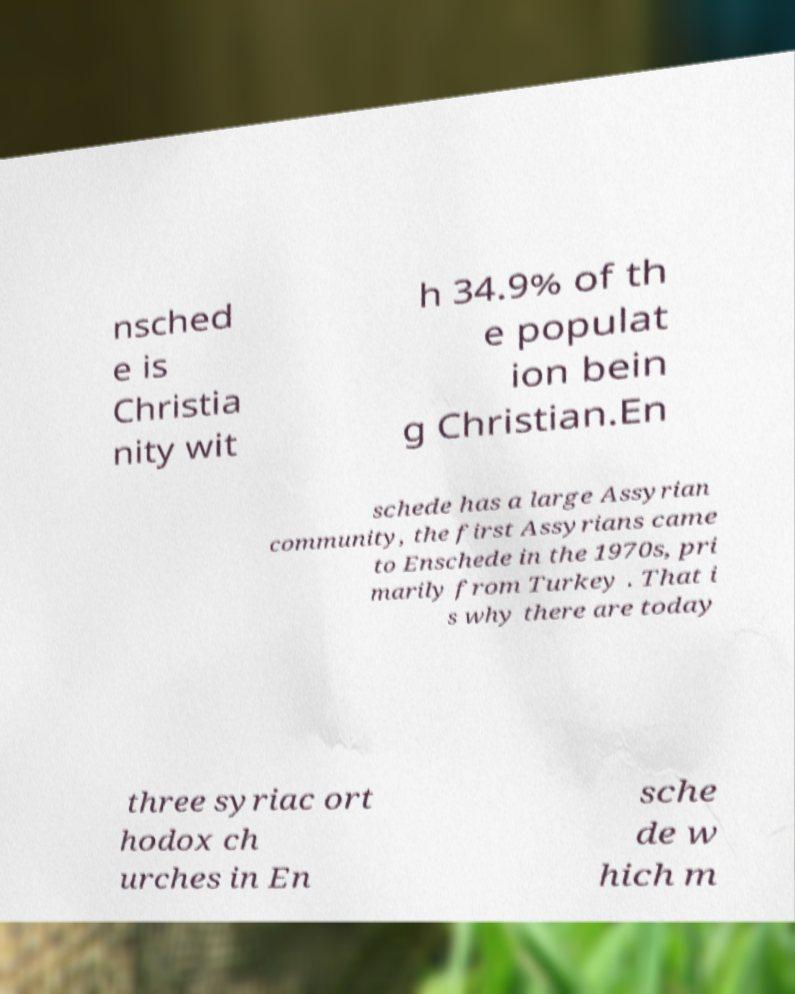Can you accurately transcribe the text from the provided image for me? nsched e is Christia nity wit h 34.9% of th e populat ion bein g Christian.En schede has a large Assyrian community, the first Assyrians came to Enschede in the 1970s, pri marily from Turkey . That i s why there are today three syriac ort hodox ch urches in En sche de w hich m 